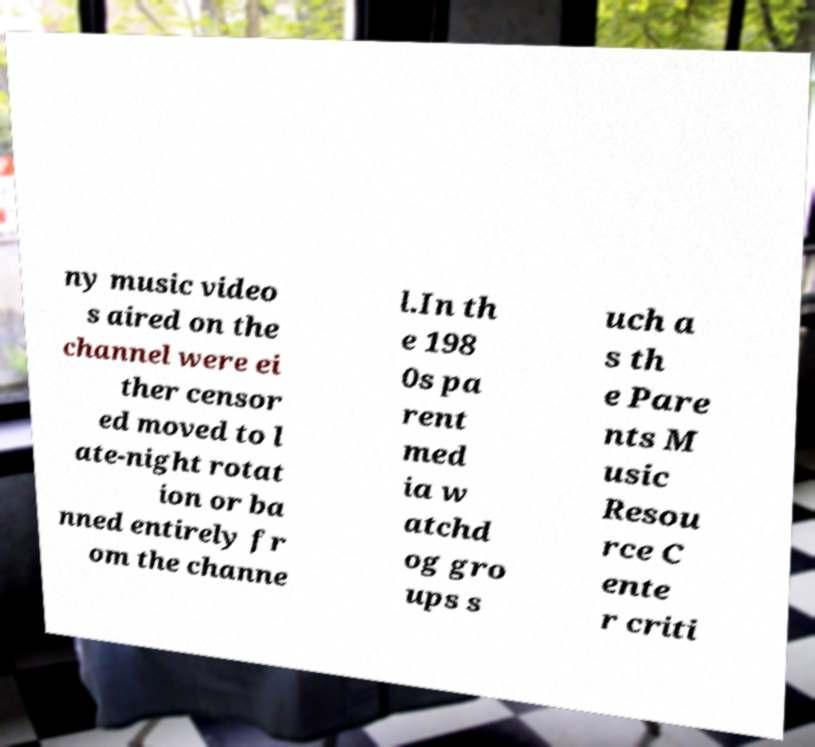There's text embedded in this image that I need extracted. Can you transcribe it verbatim? ny music video s aired on the channel were ei ther censor ed moved to l ate-night rotat ion or ba nned entirely fr om the channe l.In th e 198 0s pa rent med ia w atchd og gro ups s uch a s th e Pare nts M usic Resou rce C ente r criti 